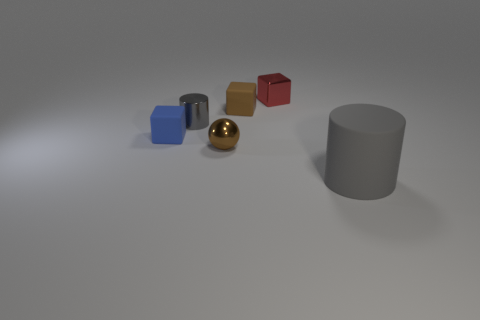Subtract all small rubber cubes. How many cubes are left? 1 Add 3 large blue rubber cubes. How many objects exist? 9 Subtract all gray blocks. Subtract all cyan cylinders. How many blocks are left? 3 Subtract all large blue shiny blocks. Subtract all big gray cylinders. How many objects are left? 5 Add 4 tiny cylinders. How many tiny cylinders are left? 5 Add 2 cyan metal cylinders. How many cyan metal cylinders exist? 2 Subtract 0 red cylinders. How many objects are left? 6 Subtract all spheres. How many objects are left? 5 